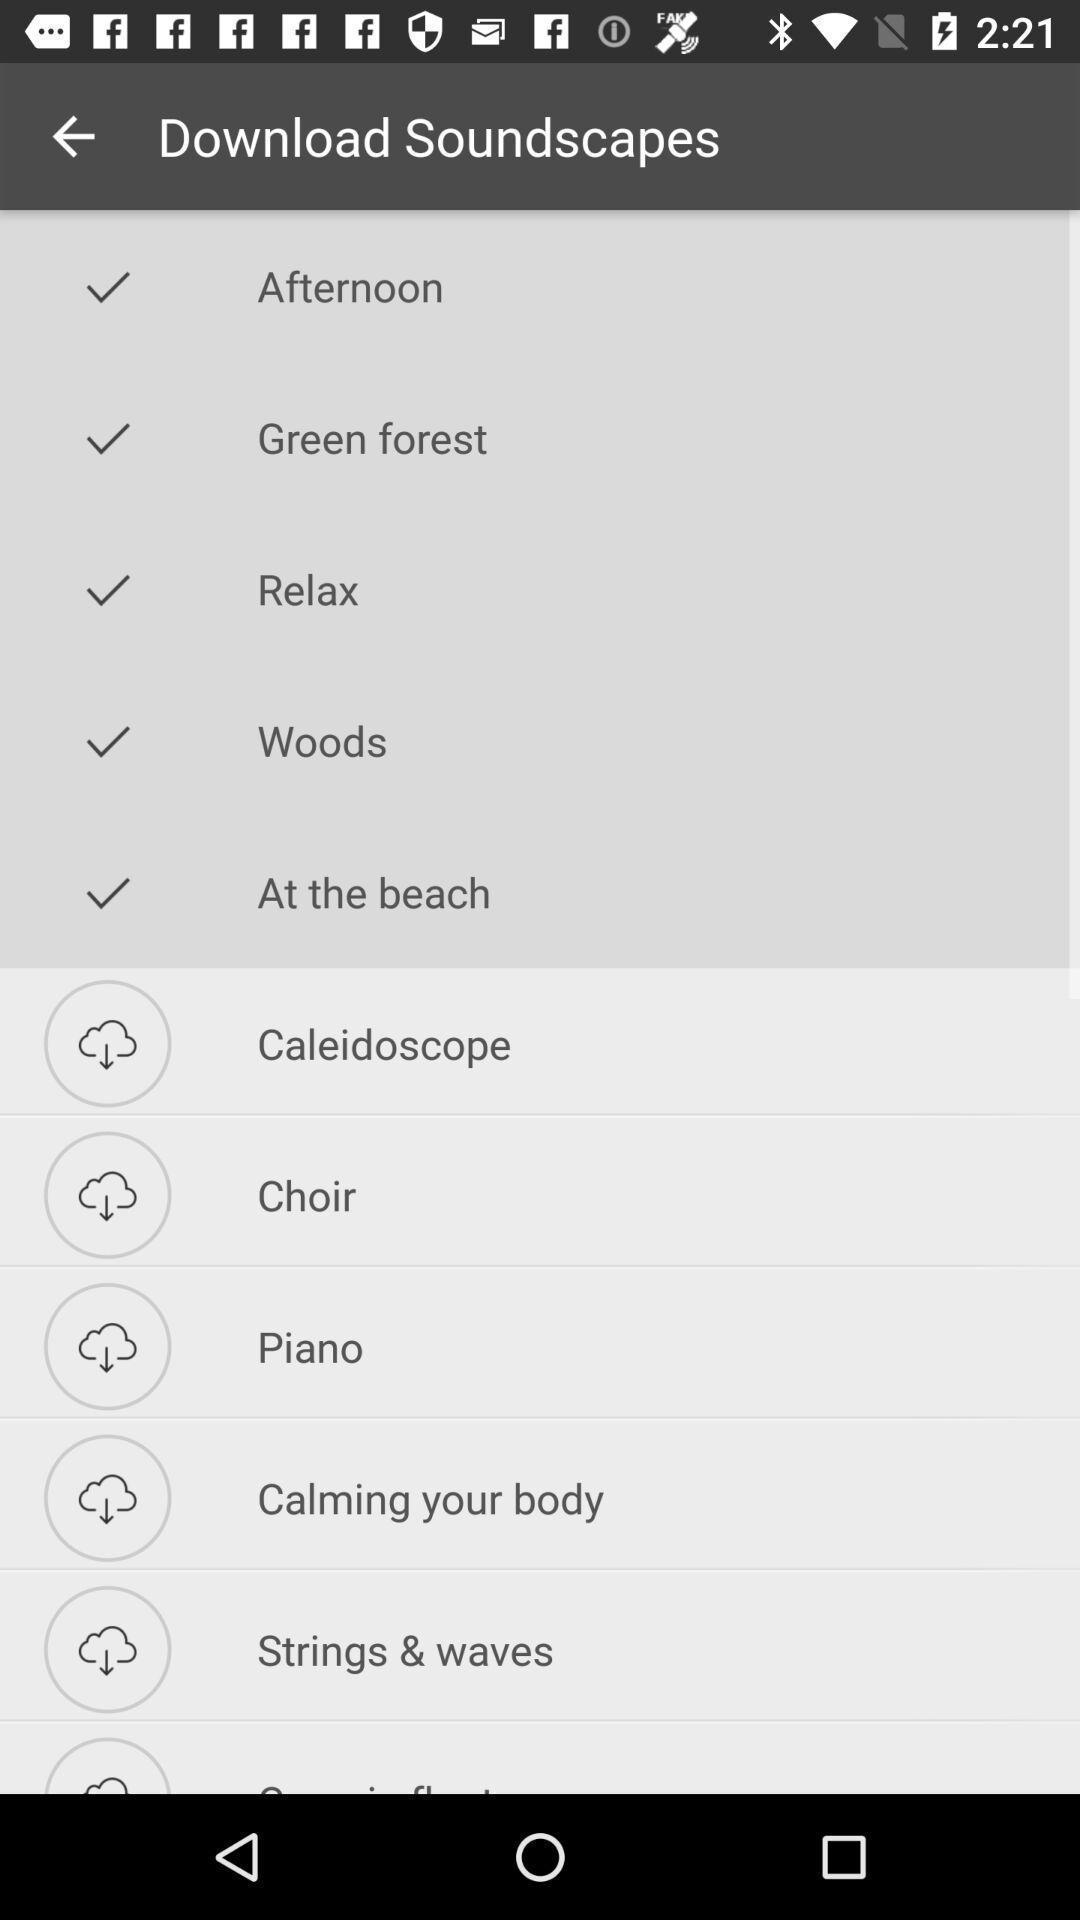What is the overall content of this screenshot? Social app showing list of download. 